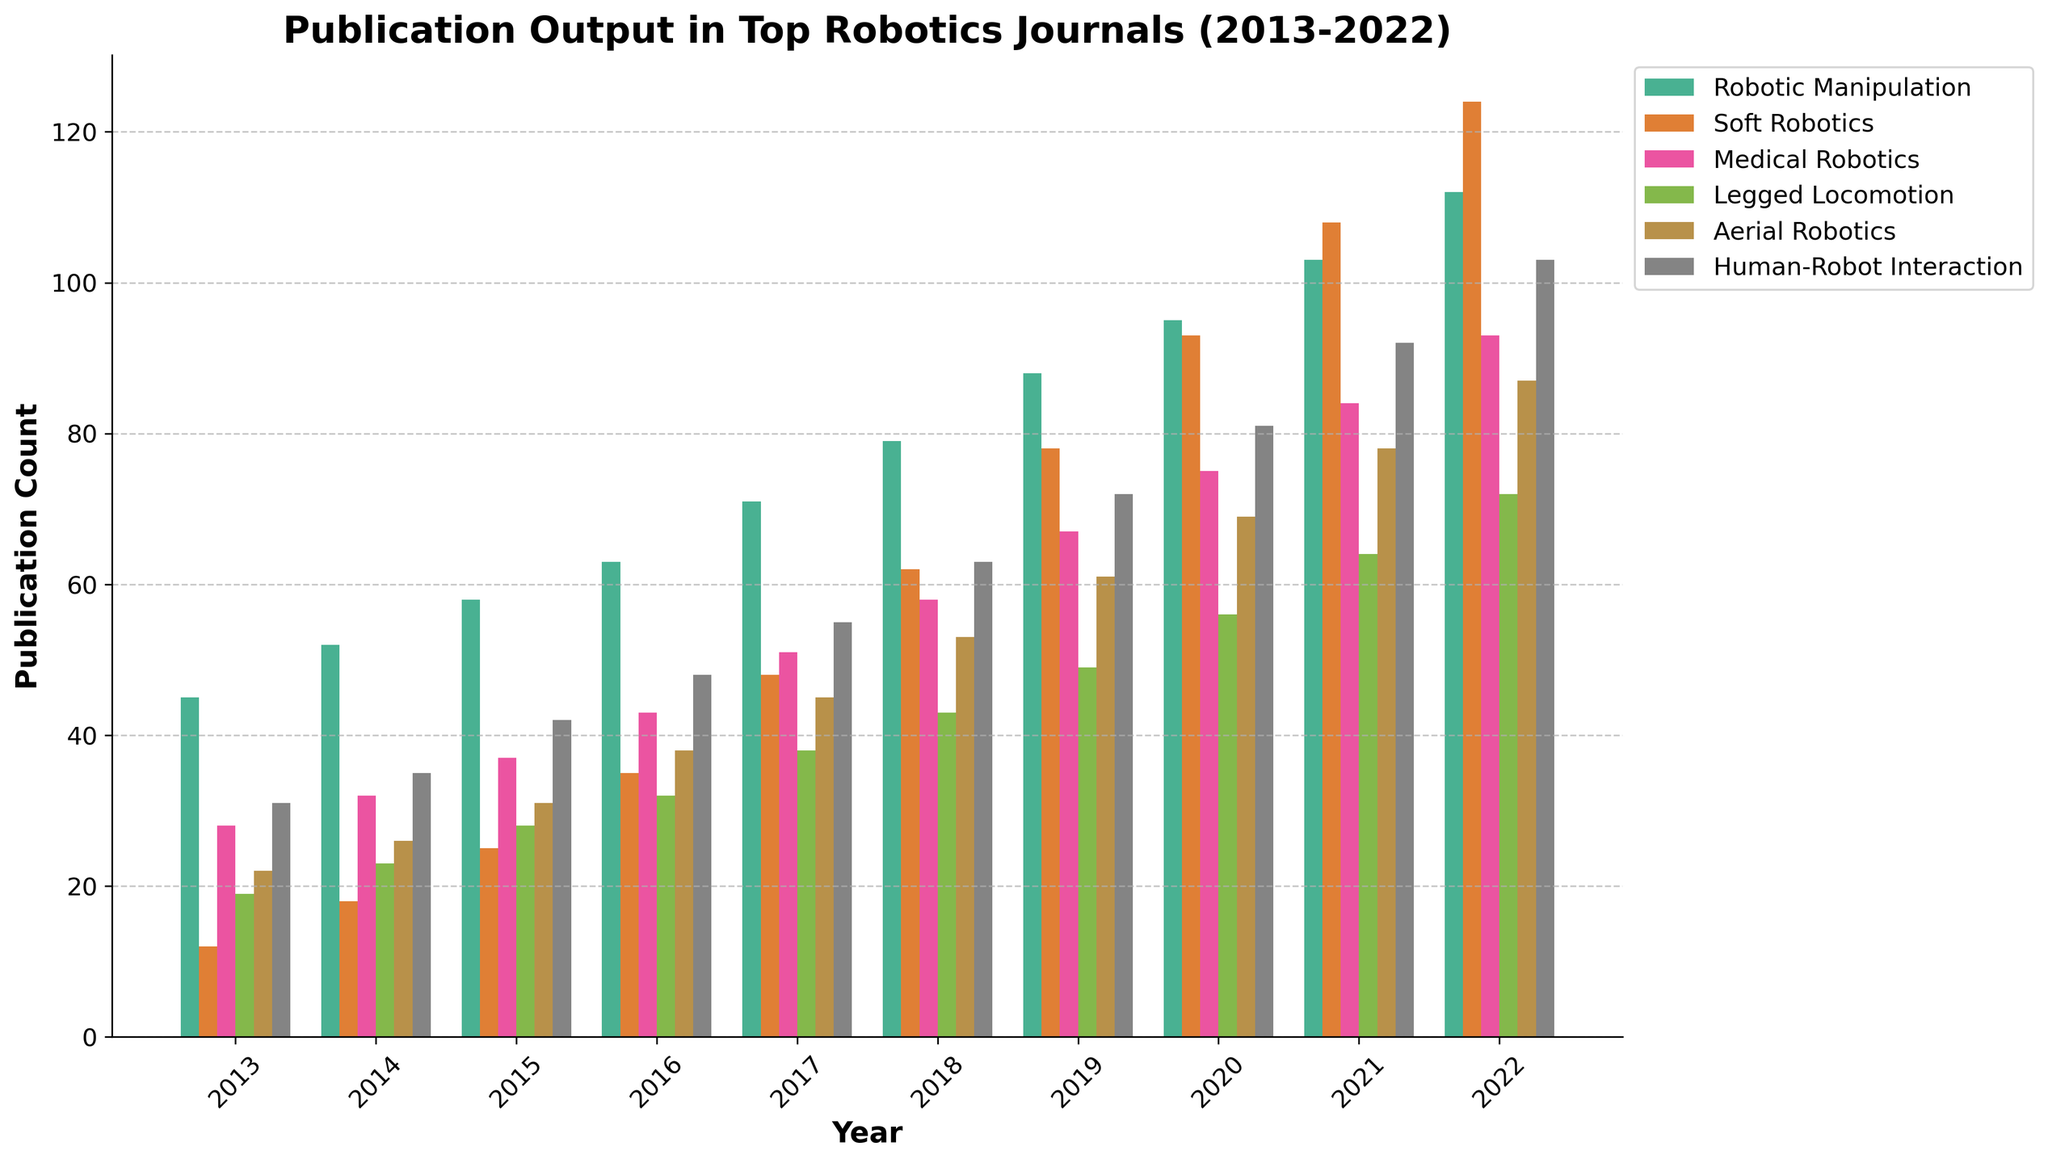What year had the highest number of publications in "Medical Robotics"? First, identify the bars representing "Medical Robotics" by looking at their color. Compare the heights of these bars across all years. The tallest bar corresponds to the year with the highest number of publications.
Answer: 2022 In which year did "Soft Robotics" first surpass the 50 publications mark? Locate the bars for "Soft Robotics" and observe their height in different years. Identify the first year in which the bar height exceeds the 50-mark point on the publication count axis.
Answer: 2017 What is the total number of publications in 2020 across all research sub-fields? Find the heights of all bars for the year 2020. Add the numbers of publications from each category: Robotic Manipulation (95), Soft Robotics (93), Medical Robotics (75), Legged Locomotion (56), Aerial Robotics (69), Human-Robot Interaction (81). The total sum is 95 + 93 + 75 + 56 + 69 + 81.
Answer: 469 What sub-field saw the highest increase in publications from 2013 to 2022? Calculate the difference in the number of publications between 2022 and 2013 for each sub-field. The differences are as follows: Robotic Manipulation (112-45), Soft Robotics (124-12), Medical Robotics (93-28), Legged Locomotion (72-19), Aerial Robotics (87-22), Human-Robot Interaction (103-31). Compare the increases to find the largest one.
Answer: Soft Robotics Which sub-field had the most consistent increase in publications over the years? Examine the bars for each sub-field from 2013 to 2022. Look at the year-to-year changes in publication count for each sub-field and identify the one with consistently increasing bar heights without significant dips.
Answer: Robotic Manipulation For which sub-field was the publication count closest to 70 in 2018? Identify the bars representing each sub-field for the year 2018. Compare their heights to see which one is closest to the 70-mark on the publication count axis.
Answer: Medical Robotics Which year saw the smallest increase in publications in "Legged Locomotion" compared to the previous year? Look at the "Legged Locomotion" bars and calculate the year-over-year differences in height. Identify the year with the smallest increase.
Answer: 2014 to 2015 In which year did "Human-Robot Interaction" first exceed the publication count of "Aerial Robotics"? Compare the bar heights of "Human-Robot Interaction" and "Aerial Robotics" across multiple years. Find the earliest year where the bar for "Human-Robot Interaction" is taller than that for "Aerial Robotics".
Answer: 2017 What is the average number of publications in "Aerial Robotics" from 2013 to 2022? Calculate the sum of the "Aerial Robotics" publication counts from each year (22 + 26 + 31 + 38 + 45 + 53 + 61 + 69 + 78 + 87). Divide this sum by the number of years (10).
Answer: 51 Which three sub-fields saw the highest number of publications in 2022? Identify the bars representing each sub-field for the year 2022. Compare their heights and find the three tallest ones.
Answer: Soft Robotics, Human-Robot Interaction, Robotic Manipulation 